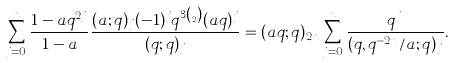<formula> <loc_0><loc_0><loc_500><loc_500>\sum _ { j = 0 } ^ { n } \frac { 1 - a q ^ { 2 j } } { 1 - a } \frac { ( a ; q ) _ { j } ( - 1 ) ^ { j } q ^ { 3 \binom { j } { 2 } } ( a q ) ^ { j } } { ( q ; q ) _ { j } } = ( a q ; q ) _ { 2 n } \sum _ { j = 0 } ^ { n } \frac { q ^ { j } } { ( q , q ^ { - 2 n } / a ; q ) _ { j } } .</formula> 